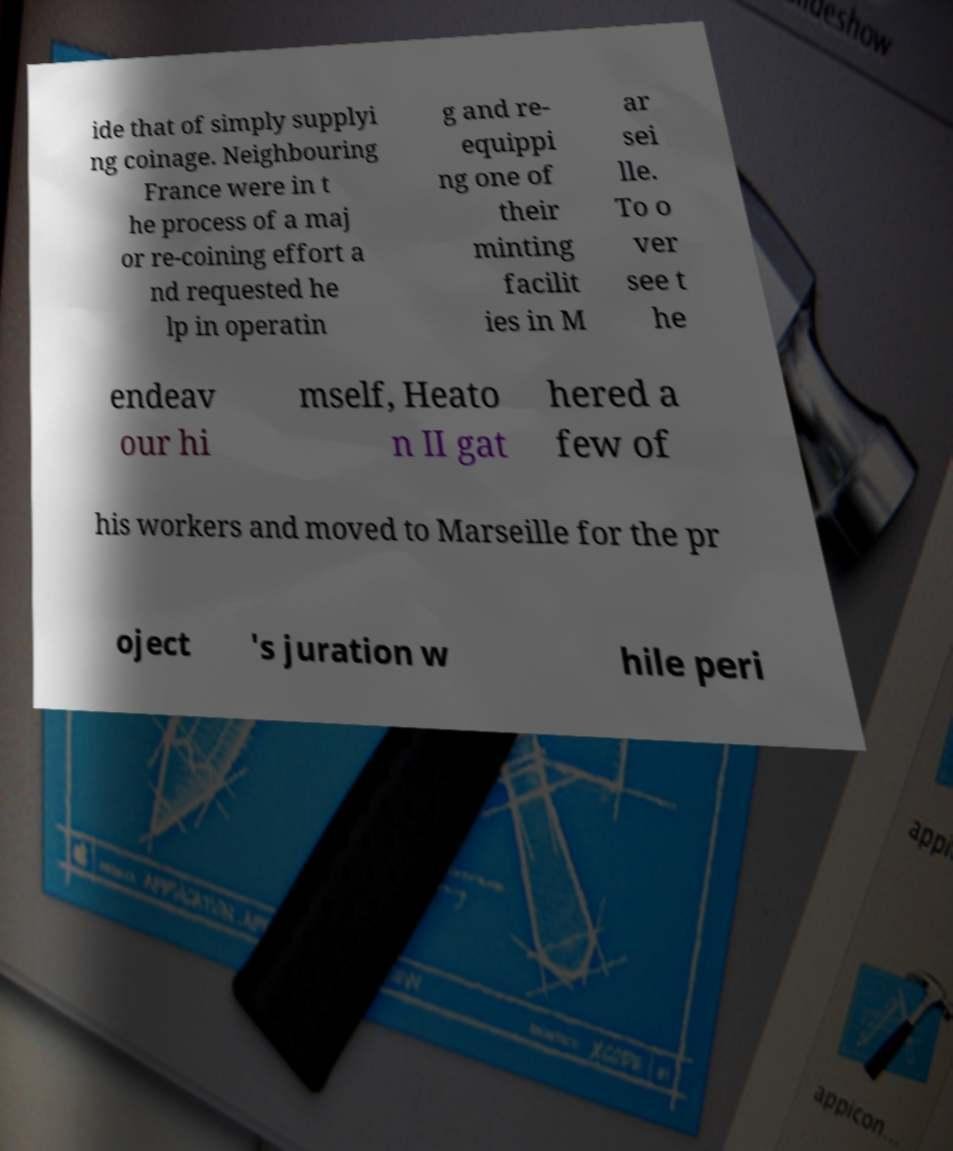Please read and relay the text visible in this image. What does it say? ide that of simply supplyi ng coinage. Neighbouring France were in t he process of a maj or re-coining effort a nd requested he lp in operatin g and re- equippi ng one of their minting facilit ies in M ar sei lle. To o ver see t he endeav our hi mself, Heato n II gat hered a few of his workers and moved to Marseille for the pr oject 's juration w hile peri 